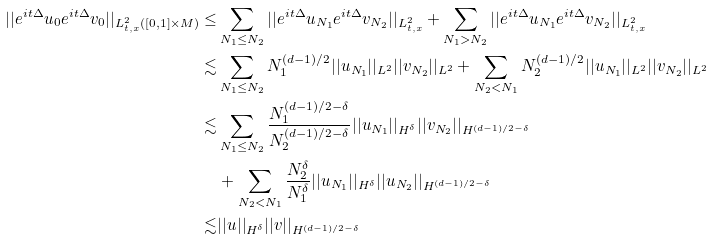<formula> <loc_0><loc_0><loc_500><loc_500>| | e ^ { i t \Delta } u _ { 0 } e ^ { i t \Delta } v _ { 0 } | | _ { L ^ { 2 } _ { t , x } ( [ 0 , 1 ] \times M ) } \leq & \sum _ { N _ { 1 } \leq N _ { 2 } } | | e ^ { i t \Delta } u _ { N _ { 1 } } e ^ { i t \Delta } v _ { N _ { 2 } } | | _ { L ^ { 2 } _ { t , x } } + \sum _ { N _ { 1 } > N _ { 2 } } | | e ^ { i t \Delta } u _ { N _ { 1 } } e ^ { i t \Delta } v _ { N _ { 2 } } | | _ { L ^ { 2 } _ { t , x } } \\ \lesssim & \sum _ { N _ { 1 } \leq N _ { 2 } } N _ { 1 } ^ { ( d - 1 ) / 2 } | | u _ { N _ { 1 } } | | _ { L ^ { 2 } } | | v _ { N _ { 2 } } | | _ { L ^ { 2 } } + \sum _ { N _ { 2 } < N _ { 1 } } N _ { 2 } ^ { ( d - 1 ) / 2 } | | u _ { N _ { 1 } } | | _ { L ^ { 2 } } | | v _ { N _ { 2 } } | | _ { L ^ { 2 } } \\ \lesssim & \sum _ { N _ { 1 } \leq N _ { 2 } } \frac { N _ { 1 } ^ { ( d - 1 ) / 2 - \delta } } { N _ { 2 } ^ { ( d - 1 ) / 2 - \delta } } | | u _ { N _ { 1 } } | | _ { H ^ { \delta } } | | v _ { N _ { 2 } } | | _ { H ^ { ( d - 1 ) / 2 - \delta } } \\ & + \sum _ { N _ { 2 } < N _ { 1 } } \frac { N _ { 2 } ^ { \delta } } { N _ { 1 } ^ { \delta } } | | u _ { N _ { 1 } } | | _ { H ^ { \delta } } | | u _ { N _ { 2 } } | | _ { H ^ { ( d - 1 ) / 2 - \delta } } \\ \lesssim & | | u | | _ { H ^ { \delta } } | | v | | _ { H ^ { ( d - 1 ) / 2 - \delta } }</formula> 